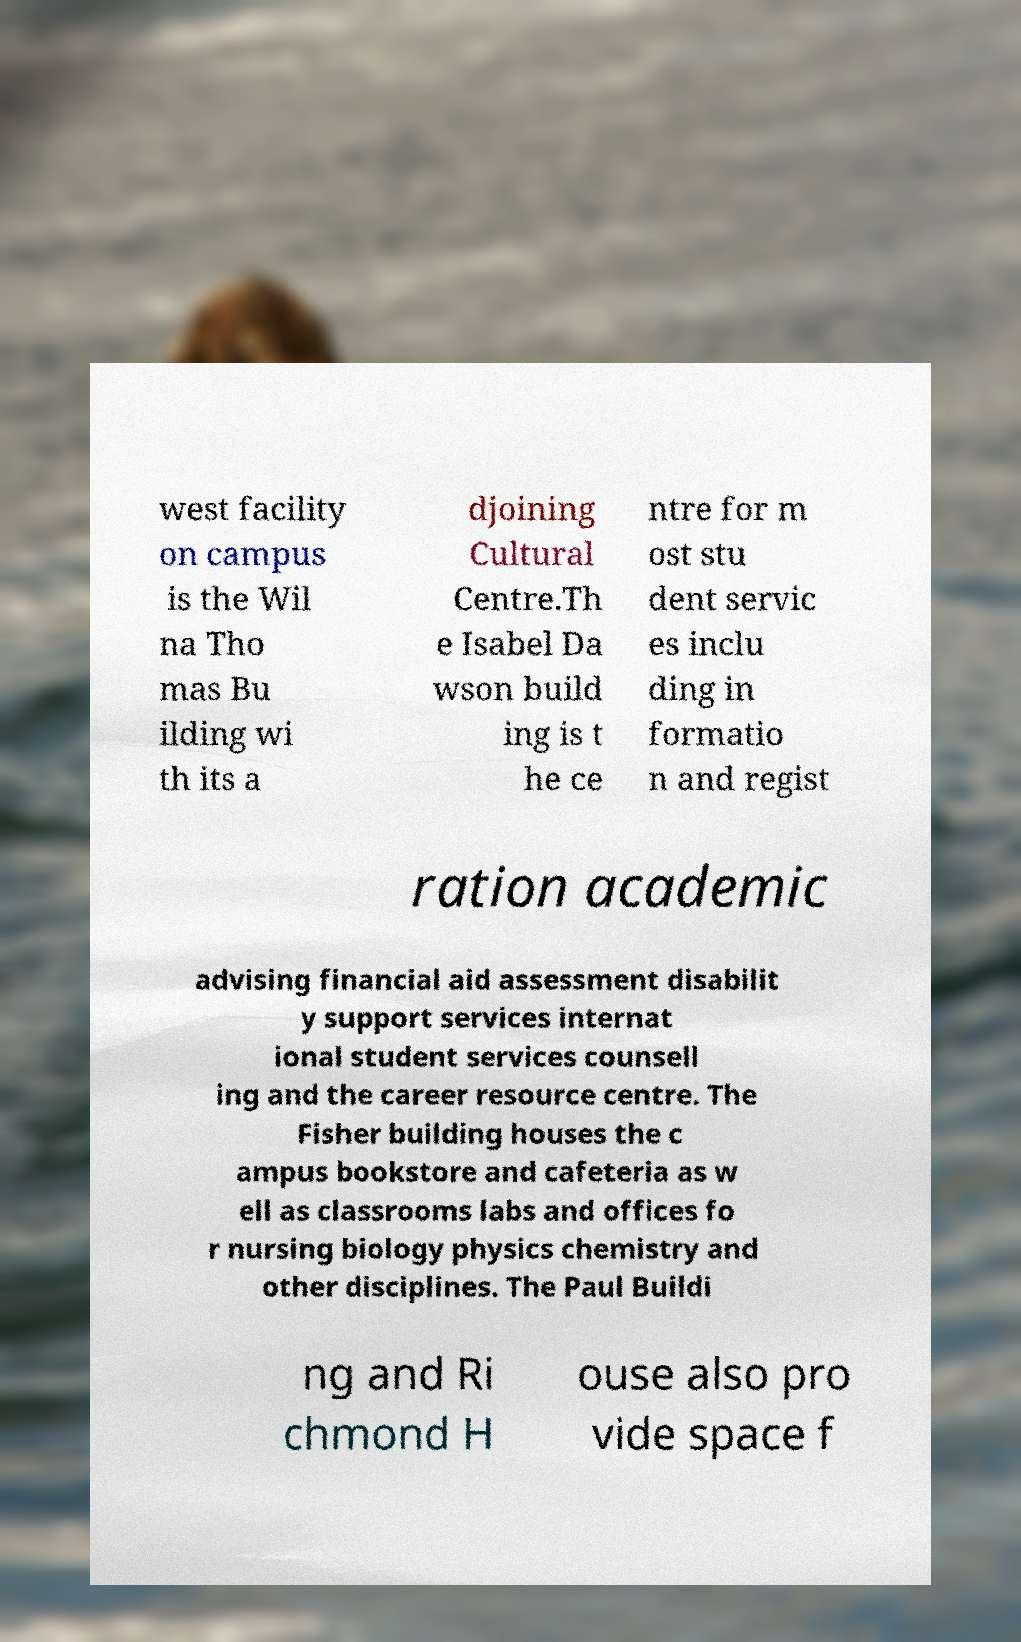Can you accurately transcribe the text from the provided image for me? west facility on campus is the Wil na Tho mas Bu ilding wi th its a djoining Cultural Centre.Th e Isabel Da wson build ing is t he ce ntre for m ost stu dent servic es inclu ding in formatio n and regist ration academic advising financial aid assessment disabilit y support services internat ional student services counsell ing and the career resource centre. The Fisher building houses the c ampus bookstore and cafeteria as w ell as classrooms labs and offices fo r nursing biology physics chemistry and other disciplines. The Paul Buildi ng and Ri chmond H ouse also pro vide space f 